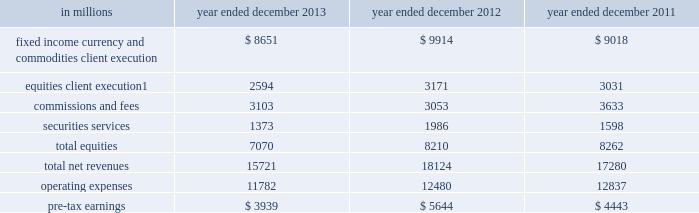Management 2019s discussion and analysis institutional client services our institutional client services segment is comprised of : fixed income , currency and commodities client execution .
Includes client execution activities related to making markets in interest rate products , credit products , mortgages , currencies and commodities .
We generate market-making revenues in these activities in three ways : 2030 in large , highly liquid markets ( such as markets for u.s .
Treasury bills or certain mortgage pass-through certificates ) , we execute a high volume of transactions for our clients for modest spreads and fees .
2030 in less liquid markets ( such as mid-cap corporate bonds , growth market currencies or certain non-agency mortgage-backed securities ) , we execute transactions for our clients for spreads and fees that are generally somewhat larger .
2030 we also structure and execute transactions involving customized or tailor-made products that address our clients 2019 risk exposures , investment objectives or other complex needs ( such as a jet fuel hedge for an airline ) .
Given the focus on the mortgage market , our mortgage activities are further described below .
Our activities in mortgages include commercial mortgage- related securities , loans and derivatives , residential mortgage-related securities , loans and derivatives ( including u.s .
Government agency-issued collateralized mortgage obligations , other prime , subprime and alt-a securities and loans ) , and other asset-backed securities , loans and derivatives .
We buy , hold and sell long and short mortgage positions , primarily for market making for our clients .
Our inventory therefore changes based on client demands and is generally held for short-term periods .
See notes 18 and 27 to the consolidated financial statements for information about exposure to mortgage repurchase requests , mortgage rescissions and mortgage-related litigation .
Equities .
Includes client execution activities related to making markets in equity products and commissions and fees from executing and clearing institutional client transactions on major stock , options and futures exchanges worldwide , as well as over-the-counter transactions .
Equities also includes our securities services business , which provides financing , securities lending and other prime brokerage services to institutional clients , including hedge funds , mutual funds , pension funds and foundations , and generates revenues primarily in the form of interest rate spreads or fees .
The table below presents the operating results of our institutional client services segment. .
In april 2013 , we completed the sale of a majority stake in our americas reinsurance business and no longer consolidate this business .
Net revenues related to the americas reinsurance business were $ 317 million for 2013 , $ 1.08 billion for 2012 and $ 880 million for 2011 .
See note 12 to the consolidated financial statements for further information about this sale .
2013 versus 2012 .
Net revenues in institutional client services were $ 15.72 billion for 2013 , 13% ( 13 % ) lower than 2012 .
Net revenues in fixed income , currency and commodities client execution were $ 8.65 billion for 2013 , 13% ( 13 % ) lower than 2012 , reflecting significantly lower net revenues in interest rate products compared with a solid 2012 , and significantly lower net revenues in mortgages compared with a strong 2012 .
The decrease in interest rate products and mortgages primarily reflected the impact of a more challenging environment and lower activity levels compared with 2012 .
In addition , net revenues in currencies were slightly lower , while net revenues in credit products and commodities were essentially unchanged compared with 2012 .
In december 2013 , we completed the sale of a majority stake in our european insurance business and recognized a gain of $ 211 million .
50 goldman sachs 2013 annual report .
What percentage of total net revenues institutional client services segment in 2012 were made up of equities client execution? 
Computations: (3171 / 18124)
Answer: 0.17496. Management 2019s discussion and analysis institutional client services our institutional client services segment is comprised of : fixed income , currency and commodities client execution .
Includes client execution activities related to making markets in interest rate products , credit products , mortgages , currencies and commodities .
We generate market-making revenues in these activities in three ways : 2030 in large , highly liquid markets ( such as markets for u.s .
Treasury bills or certain mortgage pass-through certificates ) , we execute a high volume of transactions for our clients for modest spreads and fees .
2030 in less liquid markets ( such as mid-cap corporate bonds , growth market currencies or certain non-agency mortgage-backed securities ) , we execute transactions for our clients for spreads and fees that are generally somewhat larger .
2030 we also structure and execute transactions involving customized or tailor-made products that address our clients 2019 risk exposures , investment objectives or other complex needs ( such as a jet fuel hedge for an airline ) .
Given the focus on the mortgage market , our mortgage activities are further described below .
Our activities in mortgages include commercial mortgage- related securities , loans and derivatives , residential mortgage-related securities , loans and derivatives ( including u.s .
Government agency-issued collateralized mortgage obligations , other prime , subprime and alt-a securities and loans ) , and other asset-backed securities , loans and derivatives .
We buy , hold and sell long and short mortgage positions , primarily for market making for our clients .
Our inventory therefore changes based on client demands and is generally held for short-term periods .
See notes 18 and 27 to the consolidated financial statements for information about exposure to mortgage repurchase requests , mortgage rescissions and mortgage-related litigation .
Equities .
Includes client execution activities related to making markets in equity products and commissions and fees from executing and clearing institutional client transactions on major stock , options and futures exchanges worldwide , as well as over-the-counter transactions .
Equities also includes our securities services business , which provides financing , securities lending and other prime brokerage services to institutional clients , including hedge funds , mutual funds , pension funds and foundations , and generates revenues primarily in the form of interest rate spreads or fees .
The table below presents the operating results of our institutional client services segment. .
In april 2013 , we completed the sale of a majority stake in our americas reinsurance business and no longer consolidate this business .
Net revenues related to the americas reinsurance business were $ 317 million for 2013 , $ 1.08 billion for 2012 and $ 880 million for 2011 .
See note 12 to the consolidated financial statements for further information about this sale .
2013 versus 2012 .
Net revenues in institutional client services were $ 15.72 billion for 2013 , 13% ( 13 % ) lower than 2012 .
Net revenues in fixed income , currency and commodities client execution were $ 8.65 billion for 2013 , 13% ( 13 % ) lower than 2012 , reflecting significantly lower net revenues in interest rate products compared with a solid 2012 , and significantly lower net revenues in mortgages compared with a strong 2012 .
The decrease in interest rate products and mortgages primarily reflected the impact of a more challenging environment and lower activity levels compared with 2012 .
In addition , net revenues in currencies were slightly lower , while net revenues in credit products and commodities were essentially unchanged compared with 2012 .
In december 2013 , we completed the sale of a majority stake in our european insurance business and recognized a gain of $ 211 million .
50 goldman sachs 2013 annual report .
For 2013 , operating expenses were what percent of pre-tax earnings? 
Computations: (11782 / 3939)
Answer: 2.99111. Management 2019s discussion and analysis institutional client services our institutional client services segment is comprised of : fixed income , currency and commodities client execution .
Includes client execution activities related to making markets in interest rate products , credit products , mortgages , currencies and commodities .
We generate market-making revenues in these activities in three ways : 2030 in large , highly liquid markets ( such as markets for u.s .
Treasury bills or certain mortgage pass-through certificates ) , we execute a high volume of transactions for our clients for modest spreads and fees .
2030 in less liquid markets ( such as mid-cap corporate bonds , growth market currencies or certain non-agency mortgage-backed securities ) , we execute transactions for our clients for spreads and fees that are generally somewhat larger .
2030 we also structure and execute transactions involving customized or tailor-made products that address our clients 2019 risk exposures , investment objectives or other complex needs ( such as a jet fuel hedge for an airline ) .
Given the focus on the mortgage market , our mortgage activities are further described below .
Our activities in mortgages include commercial mortgage- related securities , loans and derivatives , residential mortgage-related securities , loans and derivatives ( including u.s .
Government agency-issued collateralized mortgage obligations , other prime , subprime and alt-a securities and loans ) , and other asset-backed securities , loans and derivatives .
We buy , hold and sell long and short mortgage positions , primarily for market making for our clients .
Our inventory therefore changes based on client demands and is generally held for short-term periods .
See notes 18 and 27 to the consolidated financial statements for information about exposure to mortgage repurchase requests , mortgage rescissions and mortgage-related litigation .
Equities .
Includes client execution activities related to making markets in equity products and commissions and fees from executing and clearing institutional client transactions on major stock , options and futures exchanges worldwide , as well as over-the-counter transactions .
Equities also includes our securities services business , which provides financing , securities lending and other prime brokerage services to institutional clients , including hedge funds , mutual funds , pension funds and foundations , and generates revenues primarily in the form of interest rate spreads or fees .
The table below presents the operating results of our institutional client services segment. .
In april 2013 , we completed the sale of a majority stake in our americas reinsurance business and no longer consolidate this business .
Net revenues related to the americas reinsurance business were $ 317 million for 2013 , $ 1.08 billion for 2012 and $ 880 million for 2011 .
See note 12 to the consolidated financial statements for further information about this sale .
2013 versus 2012 .
Net revenues in institutional client services were $ 15.72 billion for 2013 , 13% ( 13 % ) lower than 2012 .
Net revenues in fixed income , currency and commodities client execution were $ 8.65 billion for 2013 , 13% ( 13 % ) lower than 2012 , reflecting significantly lower net revenues in interest rate products compared with a solid 2012 , and significantly lower net revenues in mortgages compared with a strong 2012 .
The decrease in interest rate products and mortgages primarily reflected the impact of a more challenging environment and lower activity levels compared with 2012 .
In addition , net revenues in currencies were slightly lower , while net revenues in credit products and commodities were essentially unchanged compared with 2012 .
In december 2013 , we completed the sale of a majority stake in our european insurance business and recognized a gain of $ 211 million .
50 goldman sachs 2013 annual report .
In millions , for 2013 , 2012 and 2011 , what was maximum fixed income currency and commodities client execution? 
Computations: table_max(fixed income currency and commodities client execution, none)
Answer: 9914.0. 